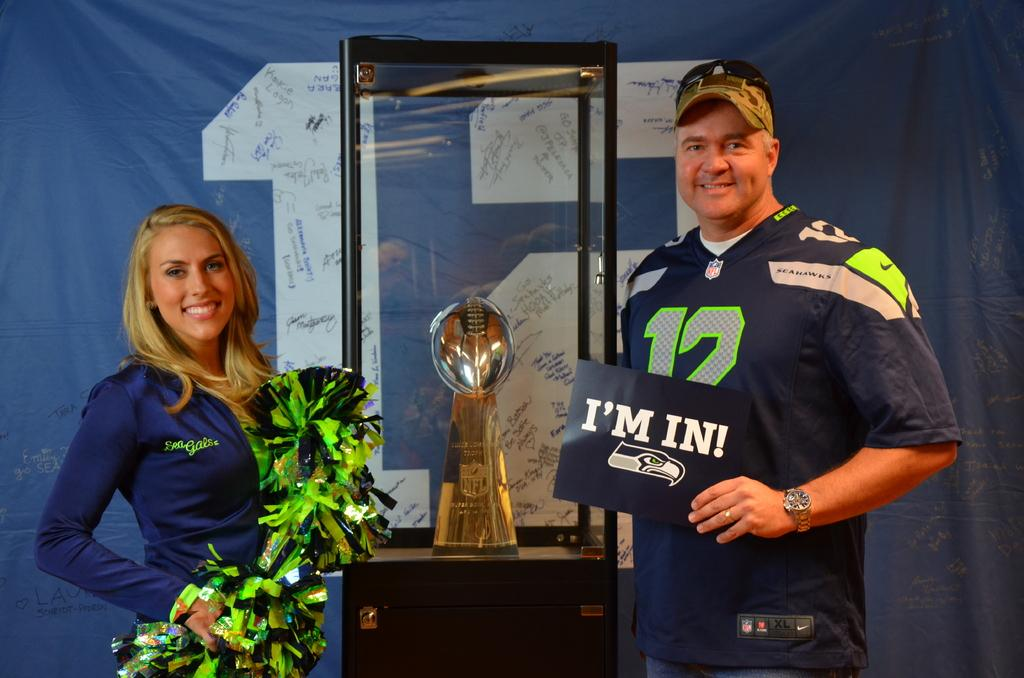<image>
Render a clear and concise summary of the photo. a man that is holding a sign that says I'm in 